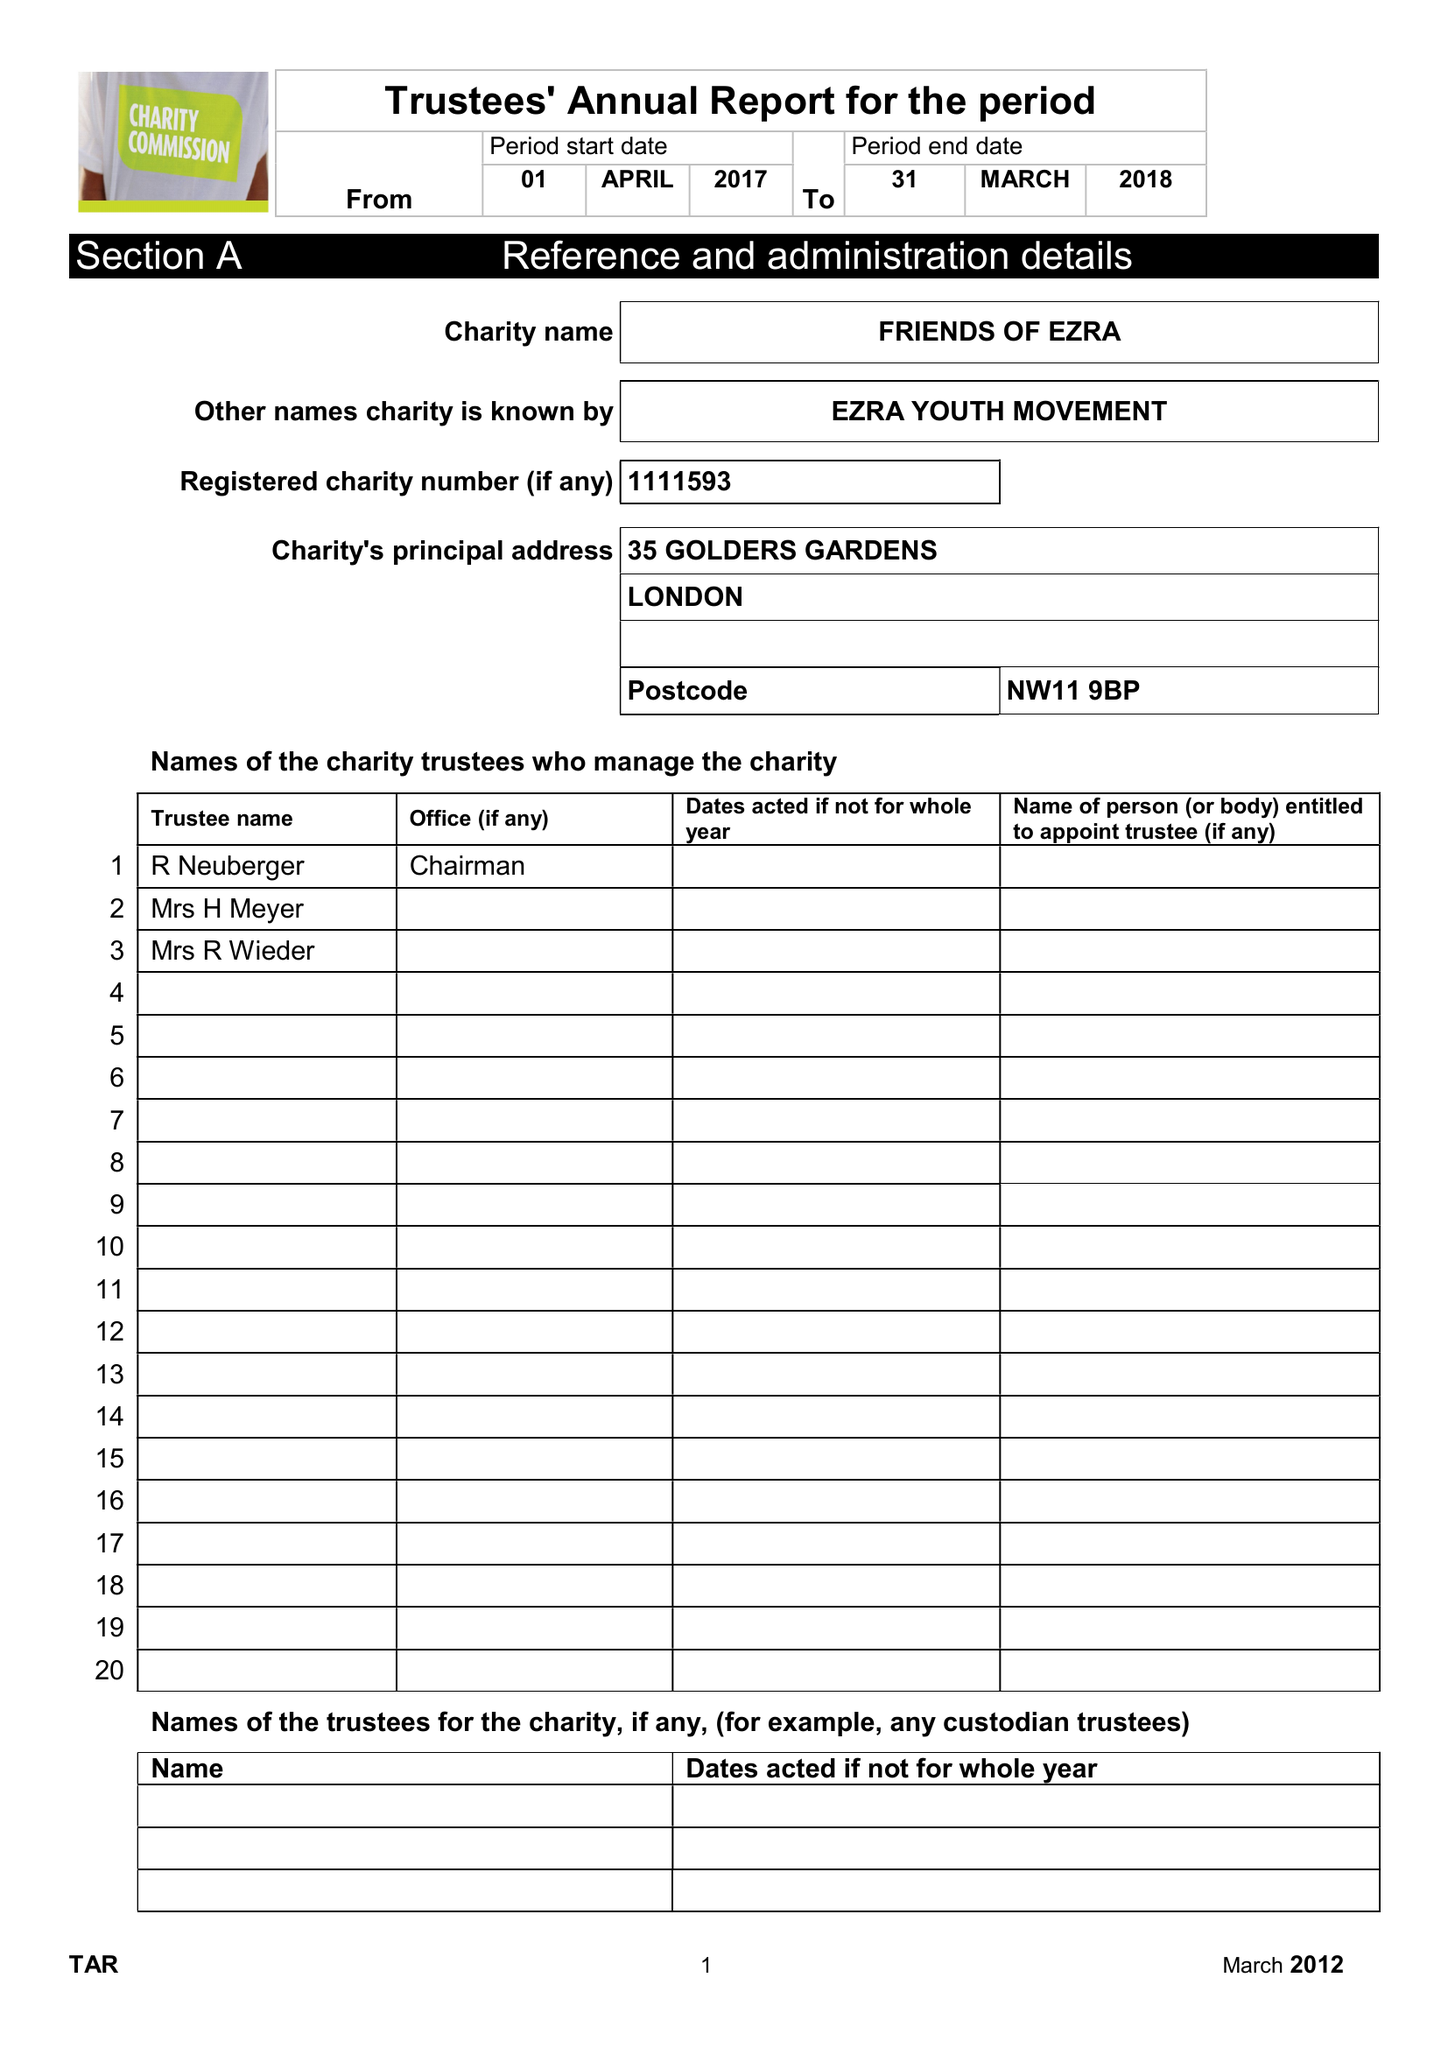What is the value for the charity_number?
Answer the question using a single word or phrase. 1111593 